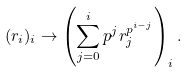<formula> <loc_0><loc_0><loc_500><loc_500>( r _ { i } ) _ { i } \to \left ( \sum _ { j = 0 } ^ { i } p ^ { j } r _ { j } ^ { p ^ { i - j } } \right ) _ { i } .</formula> 